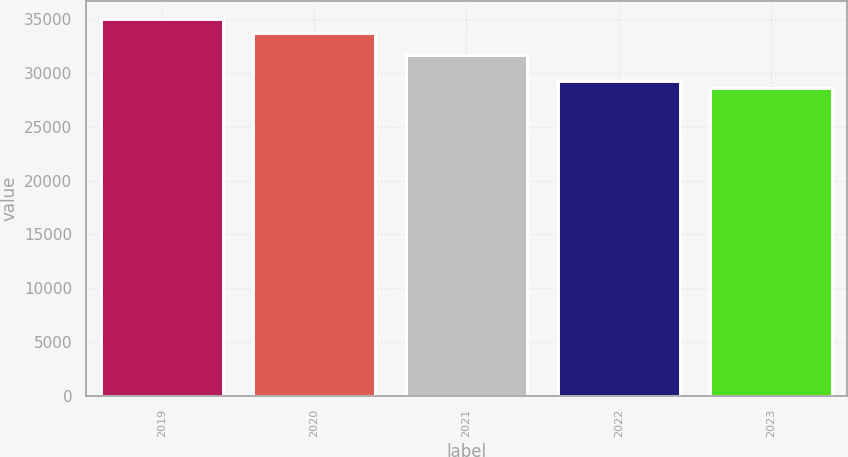Convert chart. <chart><loc_0><loc_0><loc_500><loc_500><bar_chart><fcel>2019<fcel>2020<fcel>2021<fcel>2022<fcel>2023<nl><fcel>34973<fcel>33698<fcel>31695<fcel>29268.8<fcel>28635<nl></chart> 